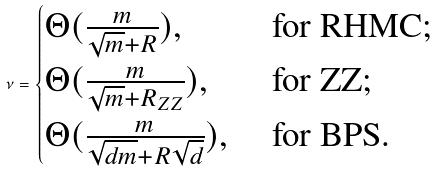Convert formula to latex. <formula><loc_0><loc_0><loc_500><loc_500>\nu = \begin{cases} \Theta ( \frac { m } { \sqrt { m } + R } ) , & \text { for RHMC;} \\ \Theta ( \frac { m } { \sqrt { m } + R _ { Z Z } } ) , & \text { for ZZ;} \\ \Theta ( \frac { m } { \sqrt { d m } + R \sqrt { d } } ) , & \text { for BPS.} \end{cases}</formula> 